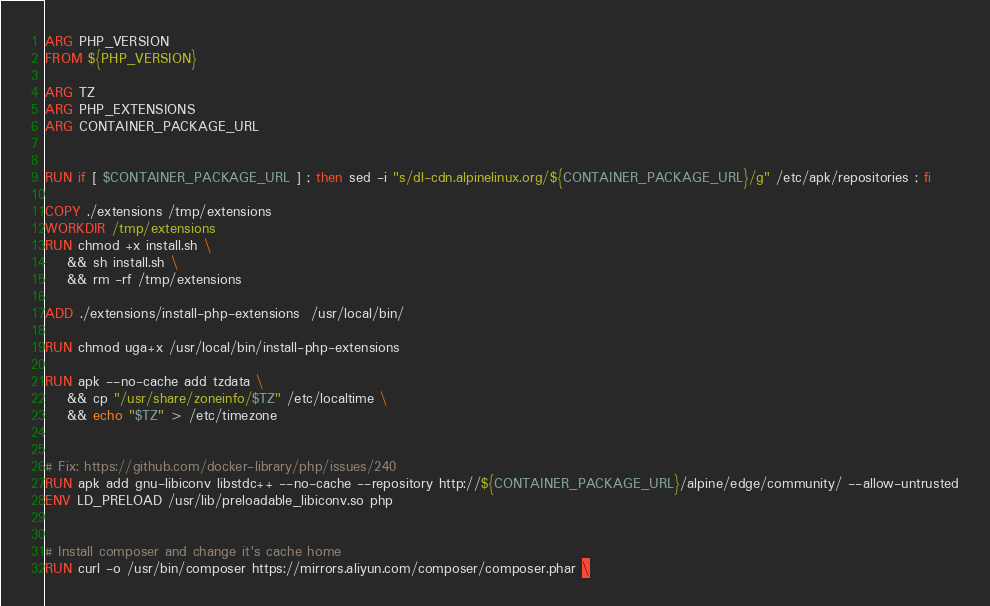<code> <loc_0><loc_0><loc_500><loc_500><_Dockerfile_>ARG PHP_VERSION
FROM ${PHP_VERSION}

ARG TZ
ARG PHP_EXTENSIONS
ARG CONTAINER_PACKAGE_URL


RUN if [ $CONTAINER_PACKAGE_URL ] ; then sed -i "s/dl-cdn.alpinelinux.org/${CONTAINER_PACKAGE_URL}/g" /etc/apk/repositories ; fi
 
COPY ./extensions /tmp/extensions
WORKDIR /tmp/extensions
RUN chmod +x install.sh \
    && sh install.sh \
    && rm -rf /tmp/extensions

ADD ./extensions/install-php-extensions  /usr/local/bin/

RUN chmod uga+x /usr/local/bin/install-php-extensions

RUN apk --no-cache add tzdata \
    && cp "/usr/share/zoneinfo/$TZ" /etc/localtime \
    && echo "$TZ" > /etc/timezone


# Fix: https://github.com/docker-library/php/issues/240
RUN apk add gnu-libiconv libstdc++ --no-cache --repository http://${CONTAINER_PACKAGE_URL}/alpine/edge/community/ --allow-untrusted
ENV LD_PRELOAD /usr/lib/preloadable_libiconv.so php


# Install composer and change it's cache home
RUN curl -o /usr/bin/composer https://mirrors.aliyun.com/composer/composer.phar \</code> 